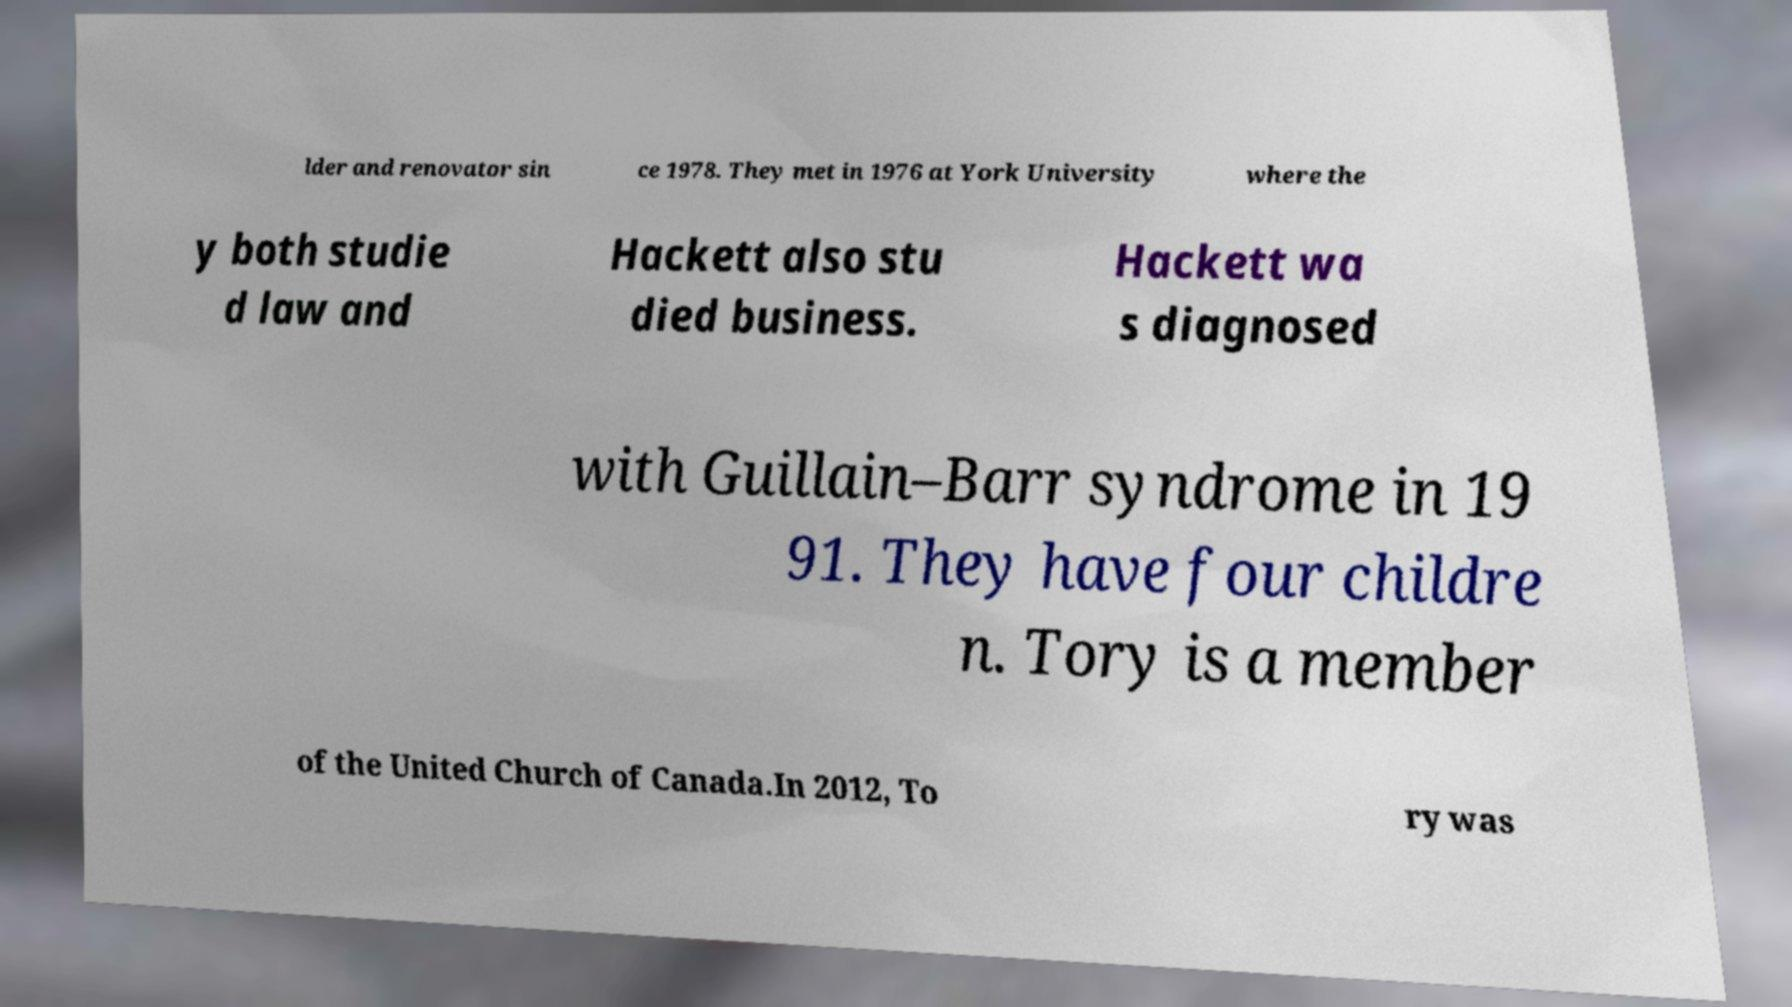Can you accurately transcribe the text from the provided image for me? lder and renovator sin ce 1978. They met in 1976 at York University where the y both studie d law and Hackett also stu died business. Hackett wa s diagnosed with Guillain–Barr syndrome in 19 91. They have four childre n. Tory is a member of the United Church of Canada.In 2012, To ry was 